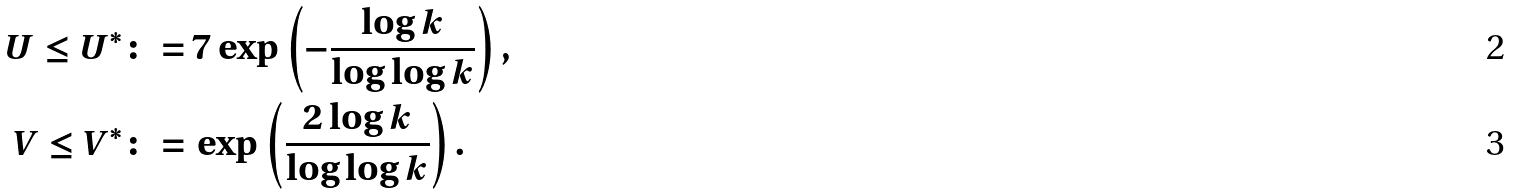Convert formula to latex. <formula><loc_0><loc_0><loc_500><loc_500>U \leq U ^ { * } \colon = & \, 7 \exp \left ( - \frac { \log k } { \log \log k } \right ) , \\ V \leq V ^ { * } \colon = & \, \exp \left ( \frac { 2 \log k } { \log \log k } \right ) .</formula> 